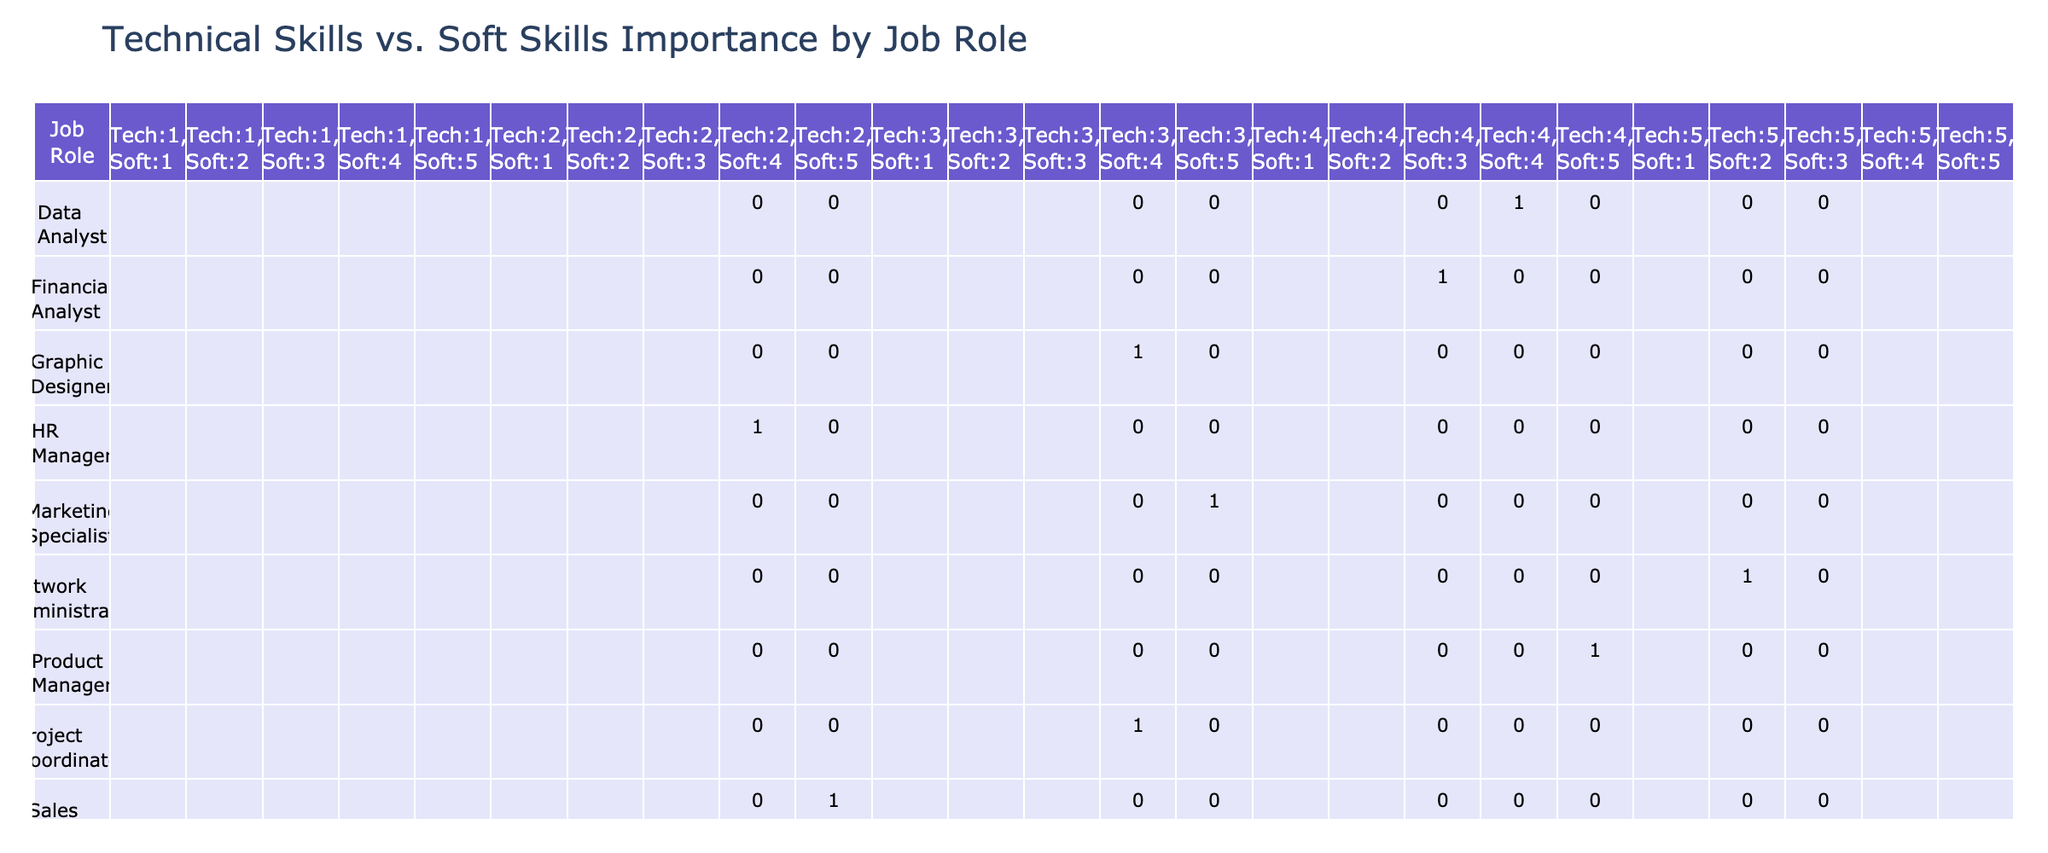What is the importance of technical skills for a Software Engineer? The table shows the Technical Skills Importance for a Software Engineer is rated as 5. This means technical skills are deemed very important for this role.
Answer: 5 Which job role has the highest importance for soft skills? Looking at the Soft Skills Importance column, the job role with the highest rating is Sales Associate, which has a score of 5.
Answer: Sales Associate What is the average importance rating for technical skills across all job roles? To find the average, we sum the technical skills ratings (5+4+4+3+3+4+2+2+5+3) = 35, and then divide by the number of job roles (10).  Thus, the average is 35/10 = 3.5.
Answer: 3.5 Is it true that the Data Analyst role considers technical skills more important than soft skills? In the table, the Technical Skills Importance for Data Analyst is 4, while Soft Skills Importance is also 4. Since both are equal, the statement is false.
Answer: No Which role shows a high importance for technical skills but low for soft skills and what are their scores? The roles that show high importance for technical skills (rating 5) but low for soft skills (rating 2) are Network Administrator. Technical Skills score is 5, and Soft Skills score is 2.
Answer: Network Administrator (Tech: 5, Soft: 2) What is the difference in scores of soft skills importance between the Product Manager and Financial Analyst roles? Soft Skills Importance for Product Manager is 5 and for Financial Analyst is 3. The difference is 5 - 3 = 2.
Answer: 2 Which job role has the lowest importance rating for technical skills? In reviewing the Technical Skills Importance column, the job role that has the lowest rating is Sales Associate with a score of 2.
Answer: Sales Associate How many job roles have a technical skills importance rating of 4 or higher? According to the table, the roles with a technical skills rating of 4 or higher are Software Engineer, Data Analyst, Product Manager, and Financial Analyst, totaling 4 roles.
Answer: 4 What is the soft skills importance rating for the Graphic Designer role, and how does it compare to the HR Manager? The soft skills rating for Graphic Designer is 4 and for HR Manager is also 4. They are equal.
Answer: 4 (equal to HR Manager) 